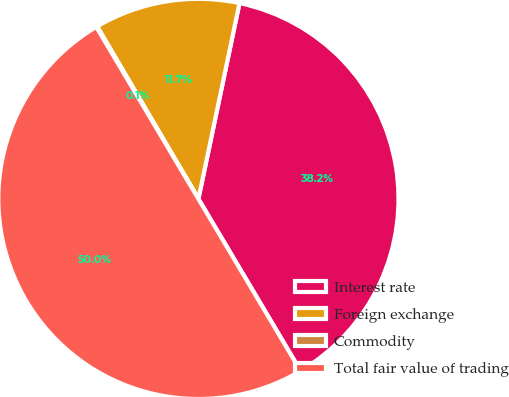Convert chart. <chart><loc_0><loc_0><loc_500><loc_500><pie_chart><fcel>Interest rate<fcel>Foreign exchange<fcel>Commodity<fcel>Total fair value of trading<nl><fcel>38.18%<fcel>11.74%<fcel>0.08%<fcel>50.0%<nl></chart> 